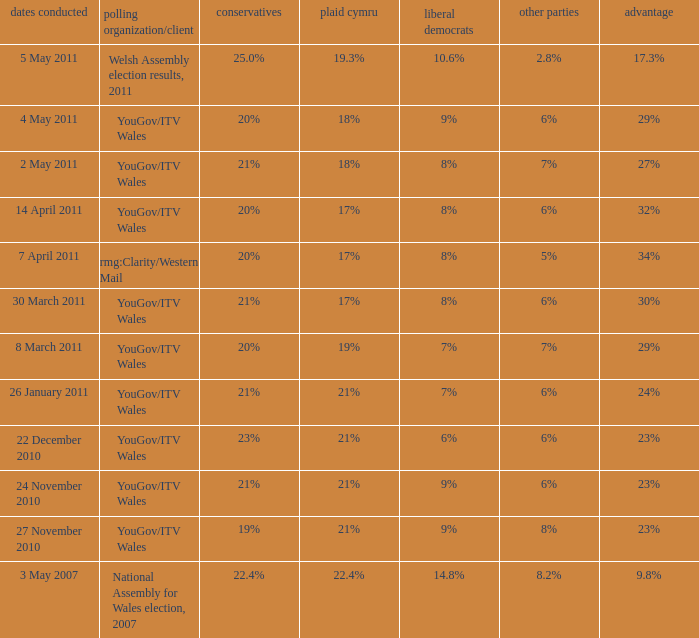What is the cons for lib dem of 8% and a lead of 27% 21%. 